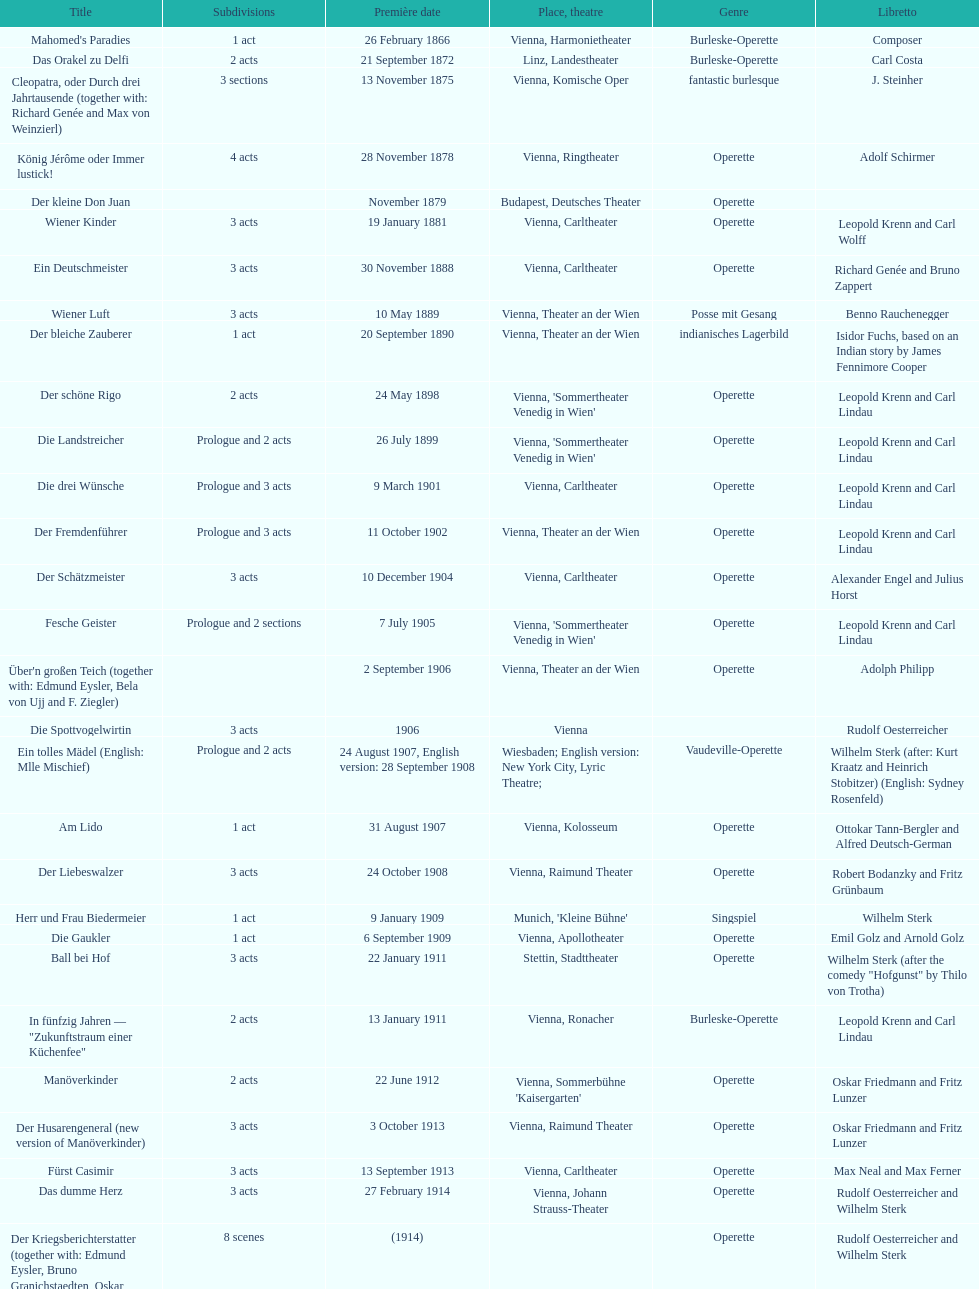In september, how many titles made their premiere? 4. 